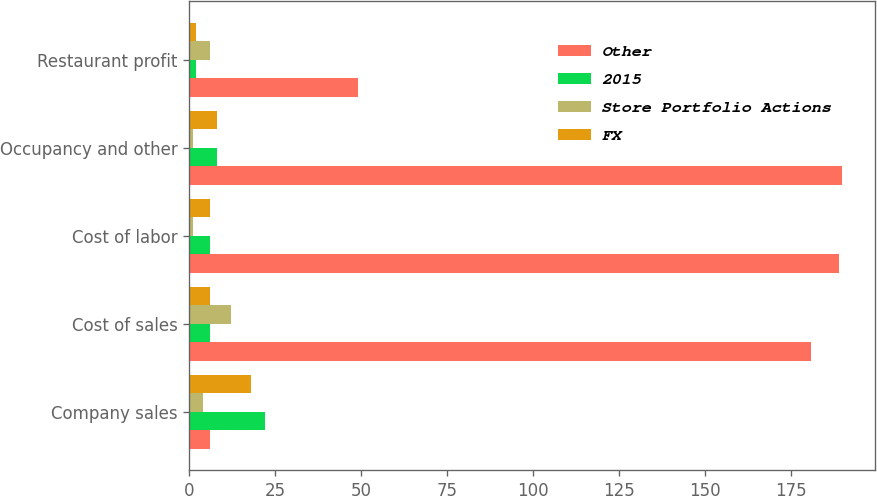<chart> <loc_0><loc_0><loc_500><loc_500><stacked_bar_chart><ecel><fcel>Company sales<fcel>Cost of sales<fcel>Cost of labor<fcel>Occupancy and other<fcel>Restaurant profit<nl><fcel>Other<fcel>6<fcel>181<fcel>189<fcel>190<fcel>49<nl><fcel>2015<fcel>22<fcel>6<fcel>6<fcel>8<fcel>2<nl><fcel>Store Portfolio Actions<fcel>4<fcel>12<fcel>1<fcel>1<fcel>6<nl><fcel>FX<fcel>18<fcel>6<fcel>6<fcel>8<fcel>2<nl></chart> 